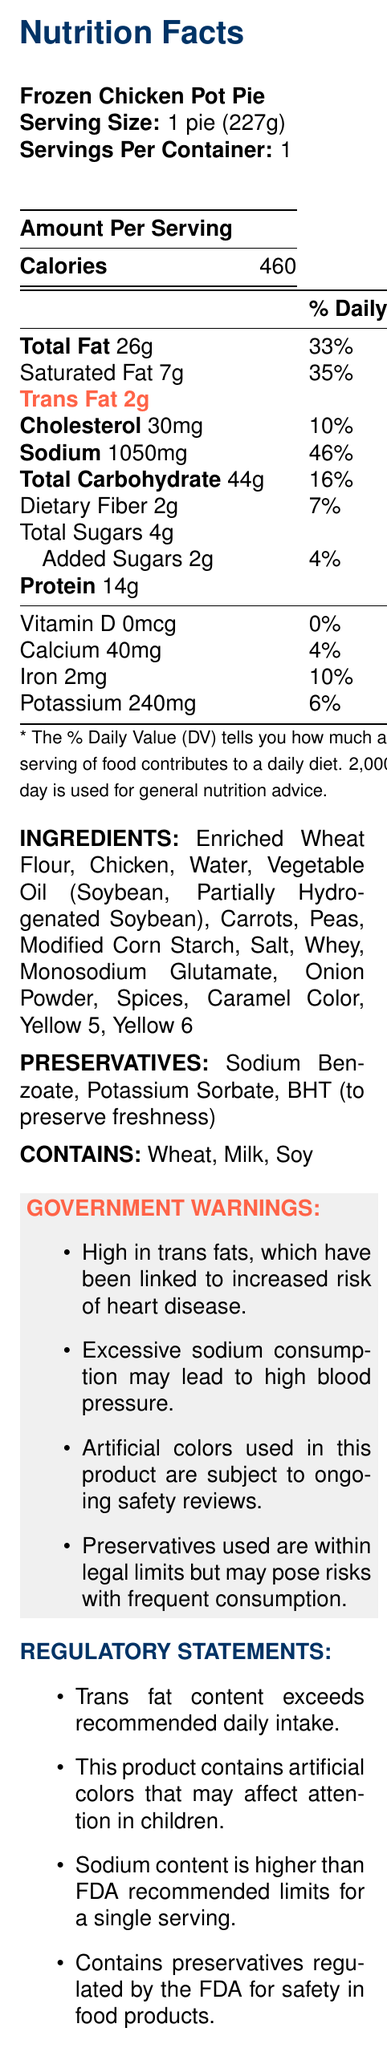what is the serving size of the Frozen Chicken Pot Pie? The serving size is specified at the top of the Nutrition Facts section.
Answer: 1 pie (227g) how many calories are there per serving? The calories per serving are clearly listed in the "Amount Per Serving" section.
Answer: 460 calories what is the total fat content in this product, and what percent of the daily value does it represent? The total fat content is 26g, and it represents 33% of the daily value as indicated in the document.
Answer: 26g, 33% how much trans fat is contained in one serving of this product? The document specifically lists "Trans Fat 2g" in the fat content section.
Answer: 2g what percentage of the daily value for sodium does this product provide? The sodium content of 1050mg makes up 46% of the daily value.
Answer: 46% does the product contain any dietary fiber? If so, how much? The document lists "Dietary Fiber 2g" indicating the presence of dietary fiber.
Answer: Yes, 2g what artificial colors are included in the ingredients of this product? The list of ingredients includes "Yellow 5" and "Yellow 6."
Answer: Yellow 5 and Yellow 6 what preservatives are used in this product? The preservative section lists Sodium Benzoate, Potassium Sorbate, and BHT.
Answer: Sodium Benzoate, Potassium Sorbate, BHT what allergens are present in this product? The document states that the product contains Wheat, Milk, and Soy.
Answer: Wheat, Milk, Soy which of the following ingredients is NOT listed in the Frozen Chicken Pot Pie? A. Potatoes B. Chicken C. Peas D. Carrots The ingredient list does not include Potatoes.
Answer: A according to the document, which health risk is associated with high trans fat consumption? I. Increased risk of heart disease II. High blood pressure III. Diabetes IV. Attention deficit in children The government warning section says high trans fats are linked to an increased risk of heart disease.
Answer: I true or false: The product contains Vitamin D. The document lists "Vitamin D 0mcg" indicating that it does not contain Vitamin D.
Answer: False summarize the main nutritional concerns highlighted in the document for this product. The document's government warnings and regulatory statements indicate significant health risks due to high trans fats, excessive sodium, and artificial colors, while preservatives are within legal limits but may pose risks with frequent consumption.
Answer: The Frozen Chicken Pot Pie has high levels of trans fat, sodium, and artificial colors, and contains preservatives. These elements are linked to various health risks including heart disease, high blood pressure, and potentially affecting children's attention. how does the amount of dietary fiber in the Frozen Chicken Pot Pie compare to its sugar content? The document lists 2g of dietary fiber and a total of 4g of sugars (including 2g of added sugar).
Answer: The product contains 2g of dietary fiber and 4g of total sugars. what is the source of iron in this product? The document does not specify the ingredient that provides iron, only listing the amount and the percent daily value.
Answer: Cannot be determined 